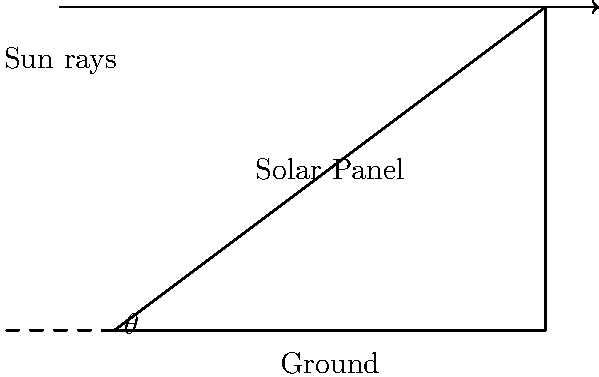Your university is planning to install solar panels on its buildings. You've been asked to help determine the optimal angle $\theta$ for maximum energy efficiency. Given that the latitude of your university is 40°N, what should be the tilt angle of the solar panels with respect to the horizontal ground? To determine the optimal tilt angle for solar panels, we can follow these steps:

1. The general rule of thumb for fixed solar panels is that the tilt angle should be approximately equal to the latitude of the location.

2. This is because the Earth's axial tilt causes the sun's position in the sky to change throughout the year, and this angle provides a good compromise for year-round energy production.

3. For locations in the Northern Hemisphere:
   - Optimal tilt angle ≈ Latitude of the location

4. Given information:
   - University latitude = 40°N

5. Therefore, the optimal tilt angle for the solar panels at your university would be approximately 40°.

6. In practice, this angle might be adjusted slightly (usually ±10-15°) based on local factors such as weather patterns, surrounding buildings, or seasonal energy demand.

7. For more precise calculations, one would need to consider factors like:
   - Seasonal variations in sun position
   - Local climate data
   - Specific energy demand patterns of the university

However, for a general estimation, using the latitude as the tilt angle provides a good starting point for maximizing year-round energy efficiency.
Answer: $40°$ 